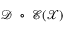<formula> <loc_0><loc_0><loc_500><loc_500>\mathcal { D } \circ \mathcal { E } ( \mathcal { X } )</formula> 